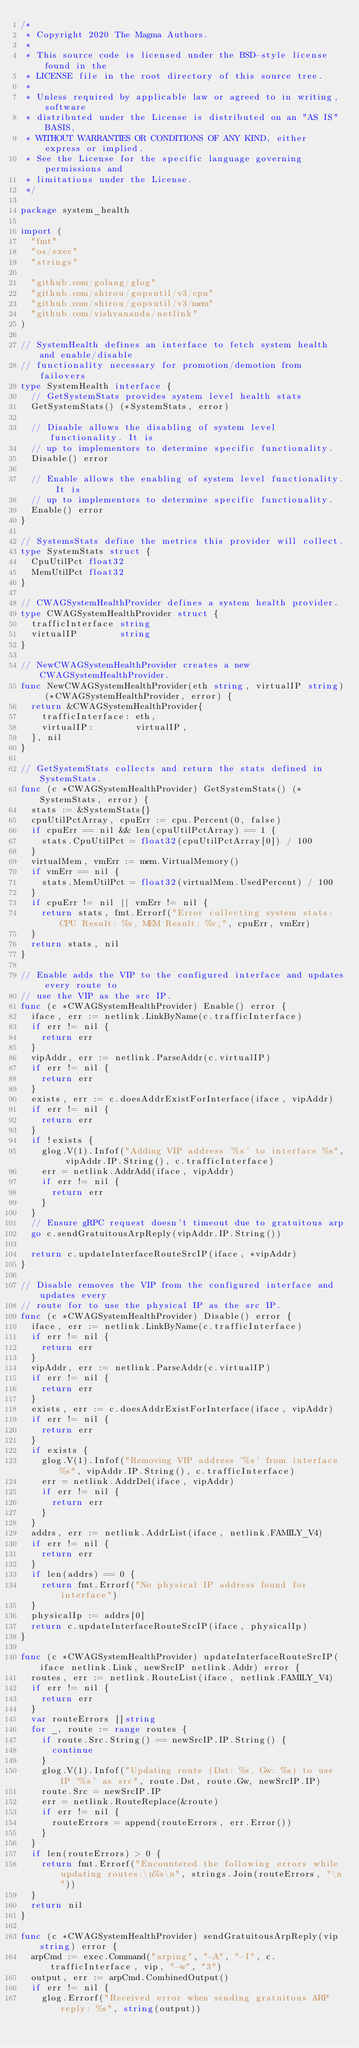Convert code to text. <code><loc_0><loc_0><loc_500><loc_500><_Go_>/*
 * Copyright 2020 The Magma Authors.
 *
 * This source code is licensed under the BSD-style license found in the
 * LICENSE file in the root directory of this source tree.
 *
 * Unless required by applicable law or agreed to in writing, software
 * distributed under the License is distributed on an "AS IS" BASIS,
 * WITHOUT WARRANTIES OR CONDITIONS OF ANY KIND, either express or implied.
 * See the License for the specific language governing permissions and
 * limitations under the License.
 */

package system_health

import (
	"fmt"
	"os/exec"
	"strings"

	"github.com/golang/glog"
	"github.com/shirou/gopsutil/v3/cpu"
	"github.com/shirou/gopsutil/v3/mem"
	"github.com/vishvananda/netlink"
)

// SystemHealth defines an interface to fetch system health and enable/disable
// functionality necessary for promotion/demotion from failovers
type SystemHealth interface {
	// GetSystemStats provides system level health stats
	GetSystemStats() (*SystemStats, error)

	// Disable allows the disabling of system level functionality. It is
	// up to implementors to determine specific functionality.
	Disable() error

	// Enable allows the enabling of system level functionality. It is
	// up to implementors to determine specific functionality.
	Enable() error
}

// SystemsStats define the metrics this provider will collect.
type SystemStats struct {
	CpuUtilPct float32
	MemUtilPct float32
}

// CWAGSystemHealthProvider defines a system health provider.
type CWAGSystemHealthProvider struct {
	trafficInterface string
	virtualIP        string
}

// NewCWAGSystemHealthProvider creates a new CWAGSystemHealthProvider.
func NewCWAGSystemHealthProvider(eth string, virtualIP string) (*CWAGSystemHealthProvider, error) {
	return &CWAGSystemHealthProvider{
		trafficInterface: eth,
		virtualIP:        virtualIP,
	}, nil
}

// GetSystemStats collects and return the stats defined in SystemStats.
func (c *CWAGSystemHealthProvider) GetSystemStats() (*SystemStats, error) {
	stats := &SystemStats{}
	cpuUtilPctArray, cpuErr := cpu.Percent(0, false)
	if cpuErr == nil && len(cpuUtilPctArray) == 1 {
		stats.CpuUtilPct = float32(cpuUtilPctArray[0]) / 100
	}
	virtualMem, vmErr := mem.VirtualMemory()
	if vmErr == nil {
		stats.MemUtilPct = float32(virtualMem.UsedPercent) / 100
	}
	if cpuErr != nil || vmErr != nil {
		return stats, fmt.Errorf("Error collecting system stats; CPU Result: %v, MEM Result: %v,", cpuErr, vmErr)
	}
	return stats, nil
}

// Enable adds the VIP to the configured interface and updates every route to
// use the VIP as the src IP.
func (c *CWAGSystemHealthProvider) Enable() error {
	iface, err := netlink.LinkByName(c.trafficInterface)
	if err != nil {
		return err
	}
	vipAddr, err := netlink.ParseAddr(c.virtualIP)
	if err != nil {
		return err
	}
	exists, err := c.doesAddrExistForInterface(iface, vipAddr)
	if err != nil {
		return err
	}
	if !exists {
		glog.V(1).Infof("Adding VIP address '%s' to interface %s", vipAddr.IP.String(), c.trafficInterface)
		err = netlink.AddrAdd(iface, vipAddr)
		if err != nil {
			return err
		}
	}
	// Ensure gRPC request doesn't timeout due to gratuitous arp
	go c.sendGratuitousArpReply(vipAddr.IP.String())

	return c.updateInterfaceRouteSrcIP(iface, *vipAddr)
}

// Disable removes the VIP from the configured interface and updates every
// route for to use the physical IP as the src IP.
func (c *CWAGSystemHealthProvider) Disable() error {
	iface, err := netlink.LinkByName(c.trafficInterface)
	if err != nil {
		return err
	}
	vipAddr, err := netlink.ParseAddr(c.virtualIP)
	if err != nil {
		return err
	}
	exists, err := c.doesAddrExistForInterface(iface, vipAddr)
	if err != nil {
		return err
	}
	if exists {
		glog.V(1).Infof("Removing VIP address '%s' from interface %s", vipAddr.IP.String(), c.trafficInterface)
		err = netlink.AddrDel(iface, vipAddr)
		if err != nil {
			return err
		}
	}
	addrs, err := netlink.AddrList(iface, netlink.FAMILY_V4)
	if err != nil {
		return err
	}
	if len(addrs) == 0 {
		return fmt.Errorf("No physical IP address found for interface")
	}
	physicalIp := addrs[0]
	return c.updateInterfaceRouteSrcIP(iface, physicalIp)
}

func (c *CWAGSystemHealthProvider) updateInterfaceRouteSrcIP(iface netlink.Link, newSrcIP netlink.Addr) error {
	routes, err := netlink.RouteList(iface, netlink.FAMILY_V4)
	if err != nil {
		return err
	}
	var routeErrors []string
	for _, route := range routes {
		if route.Src.String() == newSrcIP.IP.String() {
			continue
		}
		glog.V(1).Infof("Updating route (Dst: %s, Gw: %s) to use IP '%s' as src", route.Dst, route.Gw, newSrcIP.IP)
		route.Src = newSrcIP.IP
		err = netlink.RouteReplace(&route)
		if err != nil {
			routeErrors = append(routeErrors, err.Error())
		}
	}
	if len(routeErrors) > 0 {
		return fmt.Errorf("Encountered the following errors while updating routes:\n%s\n", strings.Join(routeErrors, "\n"))
	}
	return nil
}

func (c *CWAGSystemHealthProvider) sendGratuitousArpReply(vip string) error {
	arpCmd := exec.Command("arping", "-A", "-I", c.trafficInterface, vip, "-w", "3")
	output, err := arpCmd.CombinedOutput()
	if err != nil {
		glog.Errorf("Received error when sending gratuitous ARP reply: %s", string(output))</code> 